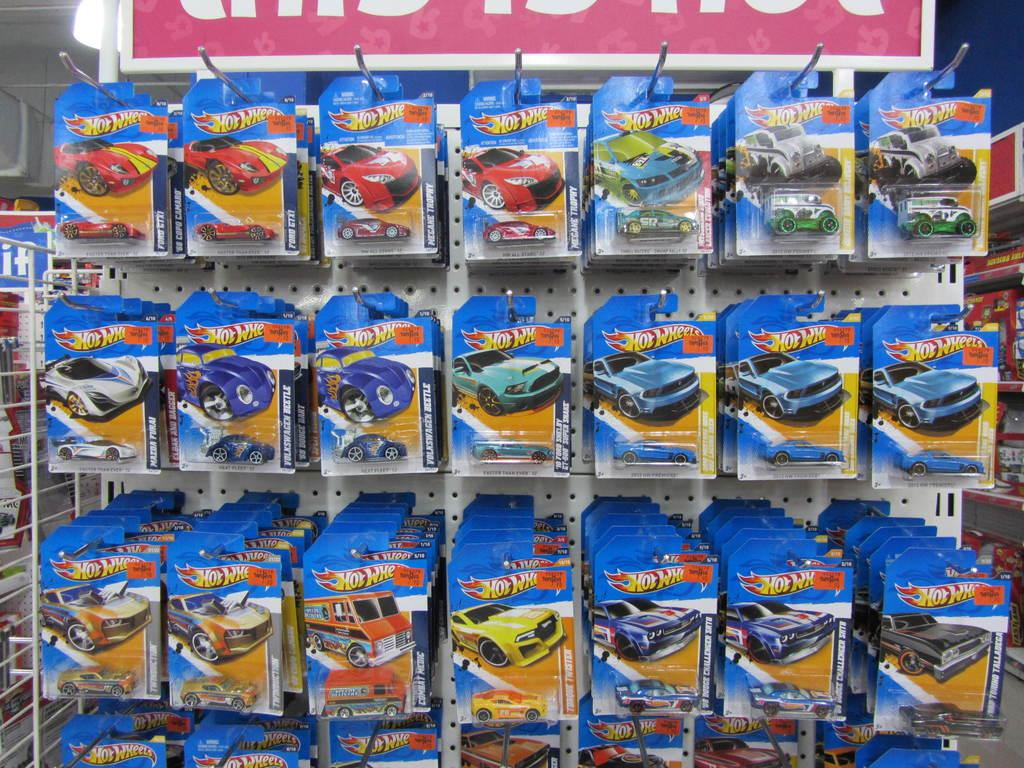What objects can be seen in the image? There are toys in the image. Where are the toys located? The toys are placed on shelves. What type of insurance is being discussed by the toys in the image? There is no discussion or mention of insurance in the image; it only features toys placed on shelves. 